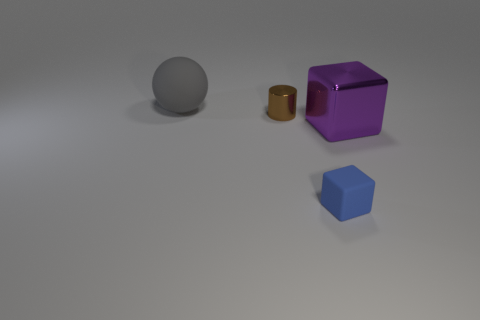There is a big thing in front of the sphere; does it have the same shape as the gray object?
Your answer should be compact. No. How many green objects are either large rubber objects or tiny objects?
Offer a very short reply. 0. How many other things are the same shape as the small matte thing?
Offer a very short reply. 1. There is a object that is to the right of the large gray rubber object and to the left of the tiny rubber cube; what shape is it?
Ensure brevity in your answer.  Cylinder. Are there any gray things in front of the purple metal cube?
Keep it short and to the point. No. There is another metallic object that is the same shape as the small blue thing; what is its size?
Offer a very short reply. Large. Are there any other things that are the same size as the brown metal cylinder?
Offer a terse response. Yes. Is the shape of the tiny brown shiny thing the same as the blue thing?
Ensure brevity in your answer.  No. There is a rubber object that is behind the matte object that is on the right side of the ball; how big is it?
Offer a very short reply. Large. What is the color of the other thing that is the same shape as the purple metallic object?
Keep it short and to the point. Blue. 